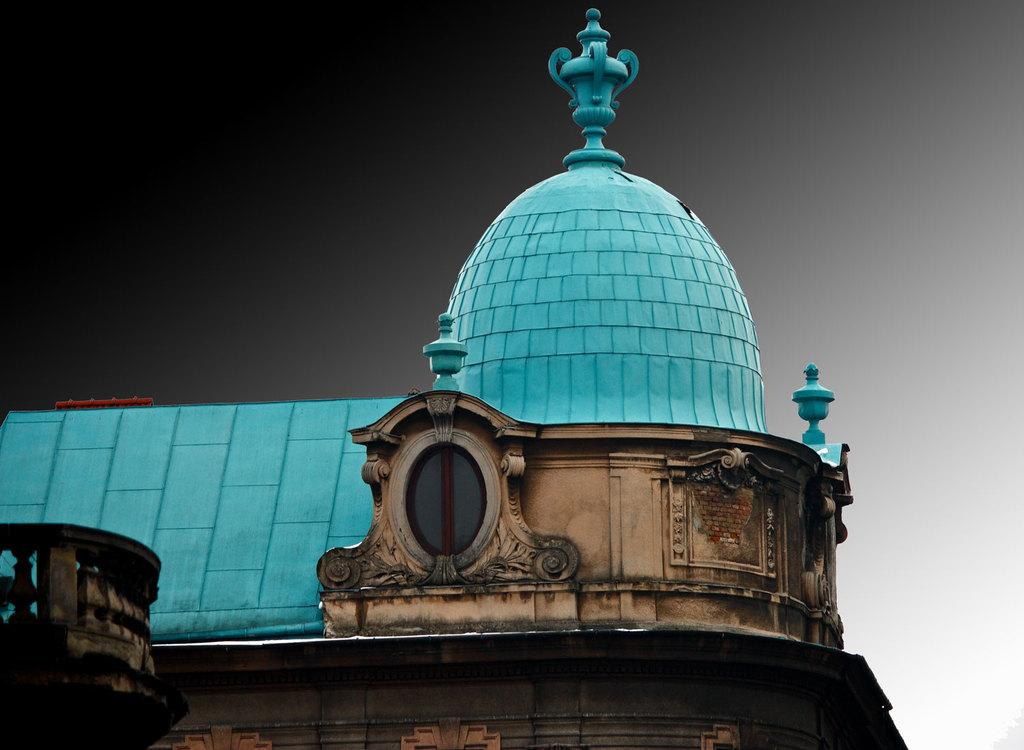What type of building is the main subject of the image? There is a tomb building in the image. What type of lunch is being served at the tomb building in the image? There is no information about lunch or any food being served in the image. The image only shows a tomb building. 